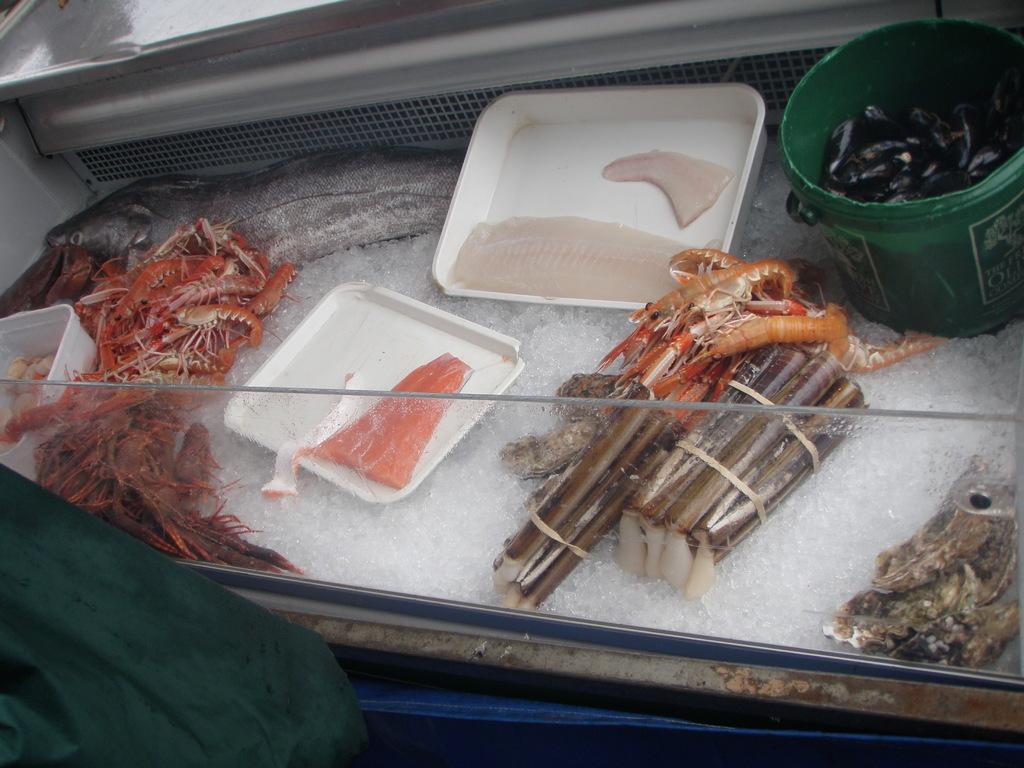Could you give a brief overview of what you see in this image? In this image, we can see some seafood kept on the ice. 